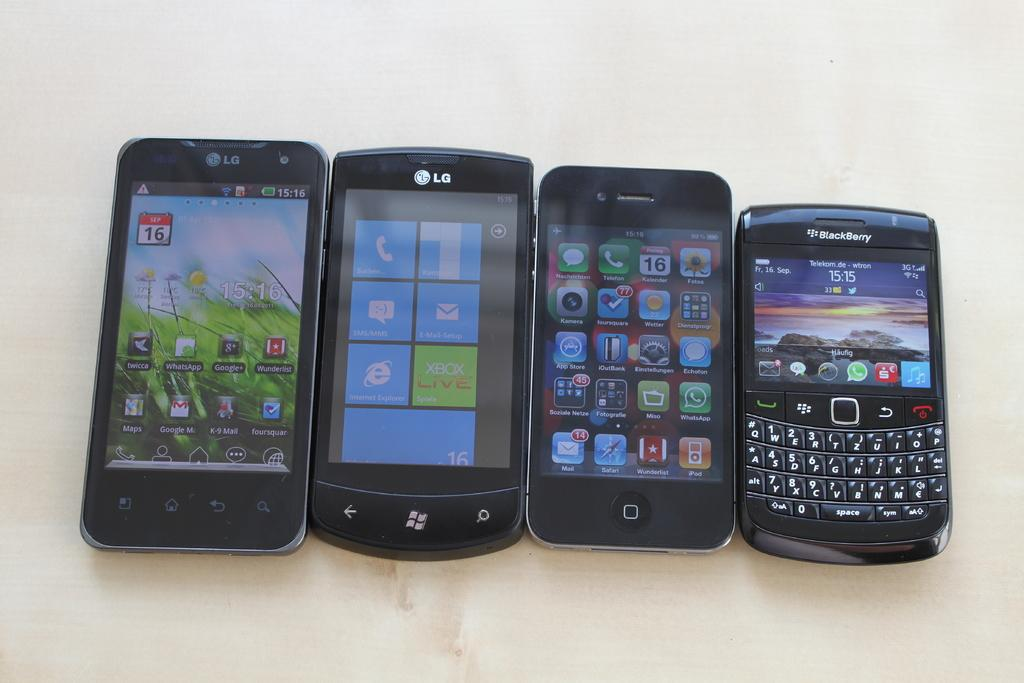Provide a one-sentence caption for the provided image. Phones from companies such as LG and Blackberry. 